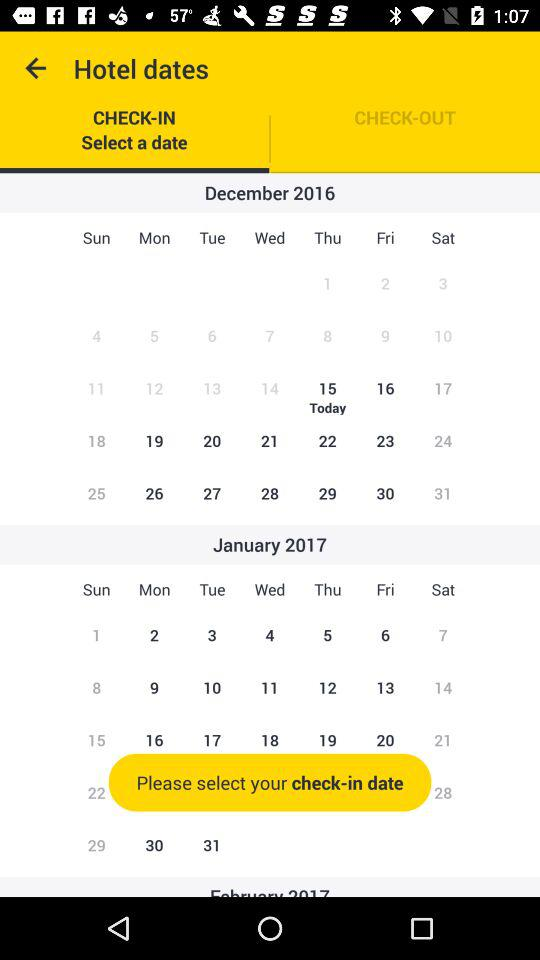What is the selected check-in date?
When the provided information is insufficient, respond with <no answer>. <no answer> 